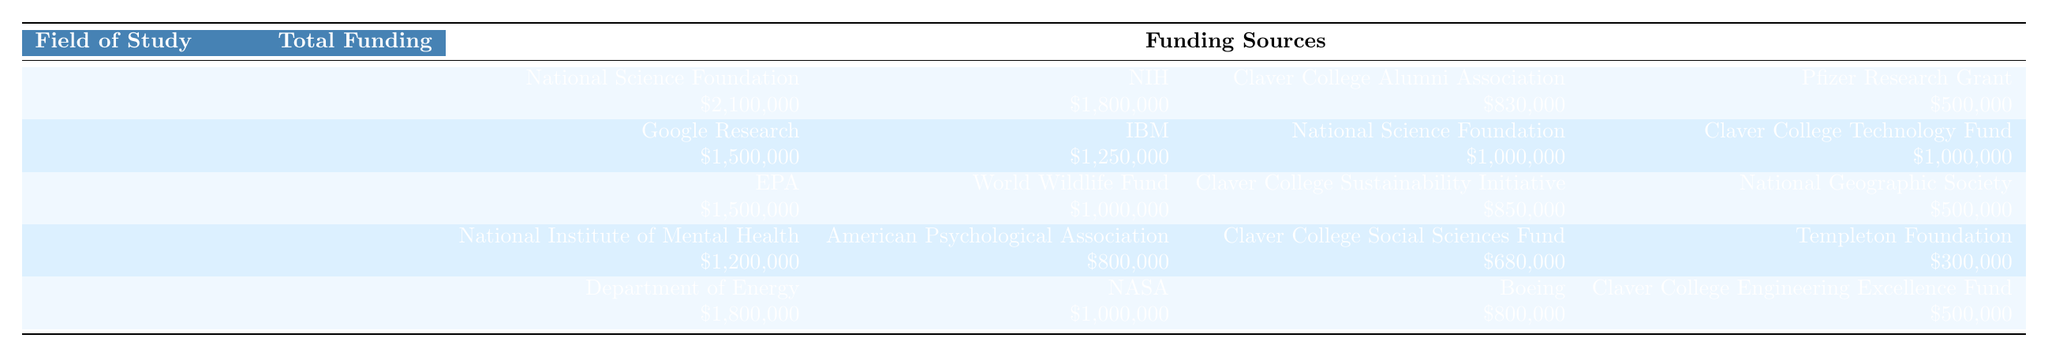What is the total funding for the Biology field of study? The table lists the total funding under the Biology field of study as "$5,230,000".
Answer: $5,230,000 Which funding source provided the highest amount for Computer Science? The highest funding source for Computer Science is Google Research, which contributed $1,500,000.
Answer: Google Research How much funding did the Claver College Alumni Association provide for Biology? The Claver College Alumni Association provided $830,000, as listed in the funding sources for Biology.
Answer: $830,000 What is the total funding received from the National Science Foundation across all fields? The National Science Foundation contributed $2,100,000 (Biology), $1,000,000 (Computer Science), and $0 (Environmental Science), so the total is $2,100,000 + $1,000,000 + $0 = $3,100,000.
Answer: $3,100,000 Did Engineering receive funding from the National Geographic Society? No, the National Geographic Society did not provide funding for Engineering; it was provided for Environmental Science.
Answer: No What is the combined total funding for Psychology and Environmental Science? The total funding for Psychology is $2,980,000 and for Environmental Science is $3,850,000. Adding these yields $2,980,000 + $3,850,000 = $6,830,000.
Answer: $6,830,000 Which field received the lowest total funding, and what was its amount? Psychology received the lowest total funding amount of $2,980,000 compared to other fields.
Answer: Psychology, $2,980,000 What percentage of the total funding for Computer Science came from Claver College Technology Fund? The Claver College Technology Fund contributed $1,000,000, which is $1,000,000/$4,750,000 = 0.2105 or 21.05% of the total funding for Computer Science.
Answer: 21.05% How much more funding does Engineering have compared to Psychology? Engineering has $4,100,000 and Psychology has $2,980,000. The difference is $4,100,000 - $2,980,000 = $1,120,000.
Answer: $1,120,000 Which funding source contributed a lesser amount to Environmental Science compared to its total funding? The total funding for Environmental Science is $3,850,000, and the funding sources include $1,500,000 (EPA), $1,000,000 (World Wildlife Fund), $850,000 (Sustainability Initiative), and $500,000 (National Geographic Society), all of which are less than $3,850,000.
Answer: All funding sources are less 